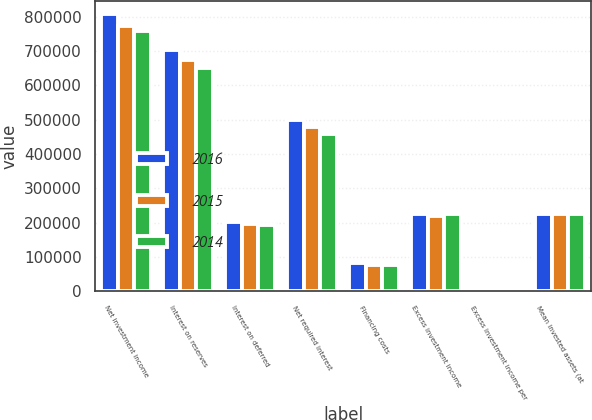Convert chart. <chart><loc_0><loc_0><loc_500><loc_500><stacked_bar_chart><ecel><fcel>Net investment income<fcel>Interest on reserves<fcel>Interest on deferred<fcel>Net required interest<fcel>Financing costs<fcel>Excess investment income<fcel>Excess investment income per<fcel>Mean invested assets (at<nl><fcel>2016<fcel>806903<fcel>702340<fcel>202813<fcel>499527<fcel>83345<fcel>224031<fcel>1.83<fcel>224031<nl><fcel>2015<fcel>773951<fcel>674650<fcel>196845<fcel>477805<fcel>76642<fcel>219504<fcel>1.73<fcel>224031<nl><fcel>2014<fcel>758286<fcel>649848<fcel>192052<fcel>457796<fcel>76126<fcel>224364<fcel>1.69<fcel>224031<nl></chart> 